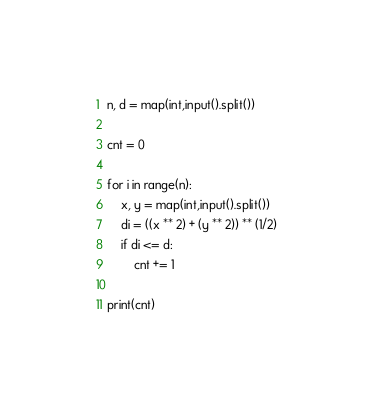<code> <loc_0><loc_0><loc_500><loc_500><_Python_>n, d = map(int,input().split())

cnt = 0

for i in range(n):
    x, y = map(int,input().split())
    di = ((x ** 2) + (y ** 2)) ** (1/2)
    if di <= d:
        cnt += 1

print(cnt)</code> 